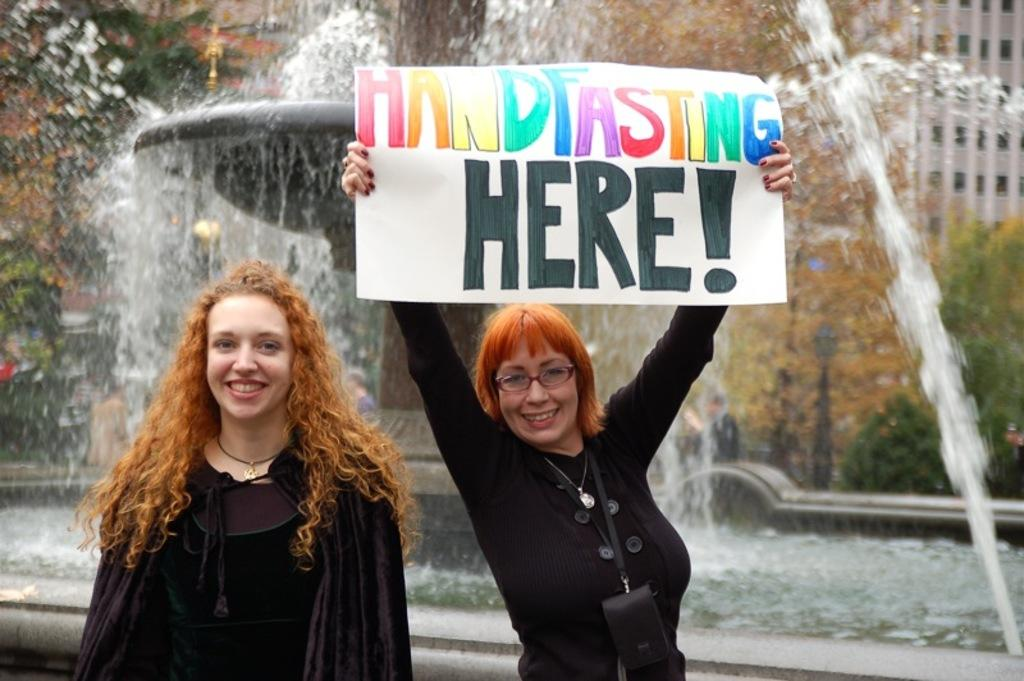How many people are in the image? There are two persons standing and smiling in the image. What is one of the persons holding in the image? There is a person holding a paper in the image. What can be seen in the background of the image? There is a sculpture water fountain, a building, and trees in the background of the image. What time of day is it in the image, and how can you tell? The time of day cannot be determined from the image, as there are no clues such as shadows or lighting to indicate morning or any other time. Can you see a tooth in the image? There is no tooth present in the image. 